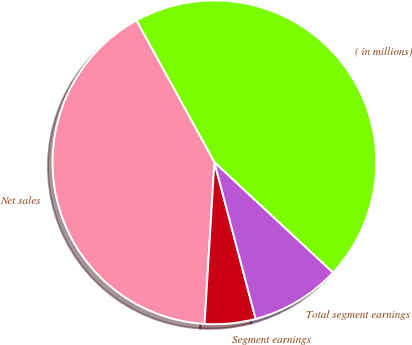<chart> <loc_0><loc_0><loc_500><loc_500><pie_chart><fcel>( in millions)<fcel>Net sales<fcel>Segment earnings<fcel>Total segment earnings<nl><fcel>44.93%<fcel>41.03%<fcel>5.07%<fcel>8.97%<nl></chart> 